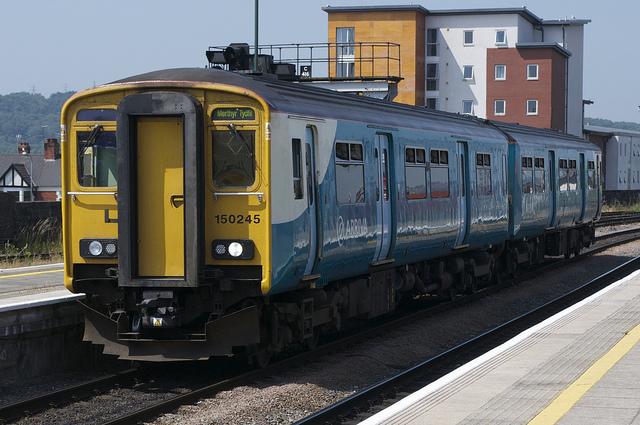Is there a yellow line on the ground?
Concise answer only. Yes. Is the train parked?
Concise answer only. Yes. What is the number on front of the train?
Write a very short answer. 150245. How many doors are on the side of the train?
Short answer required. 6. Is the train under the bridge?
Write a very short answer. No. 